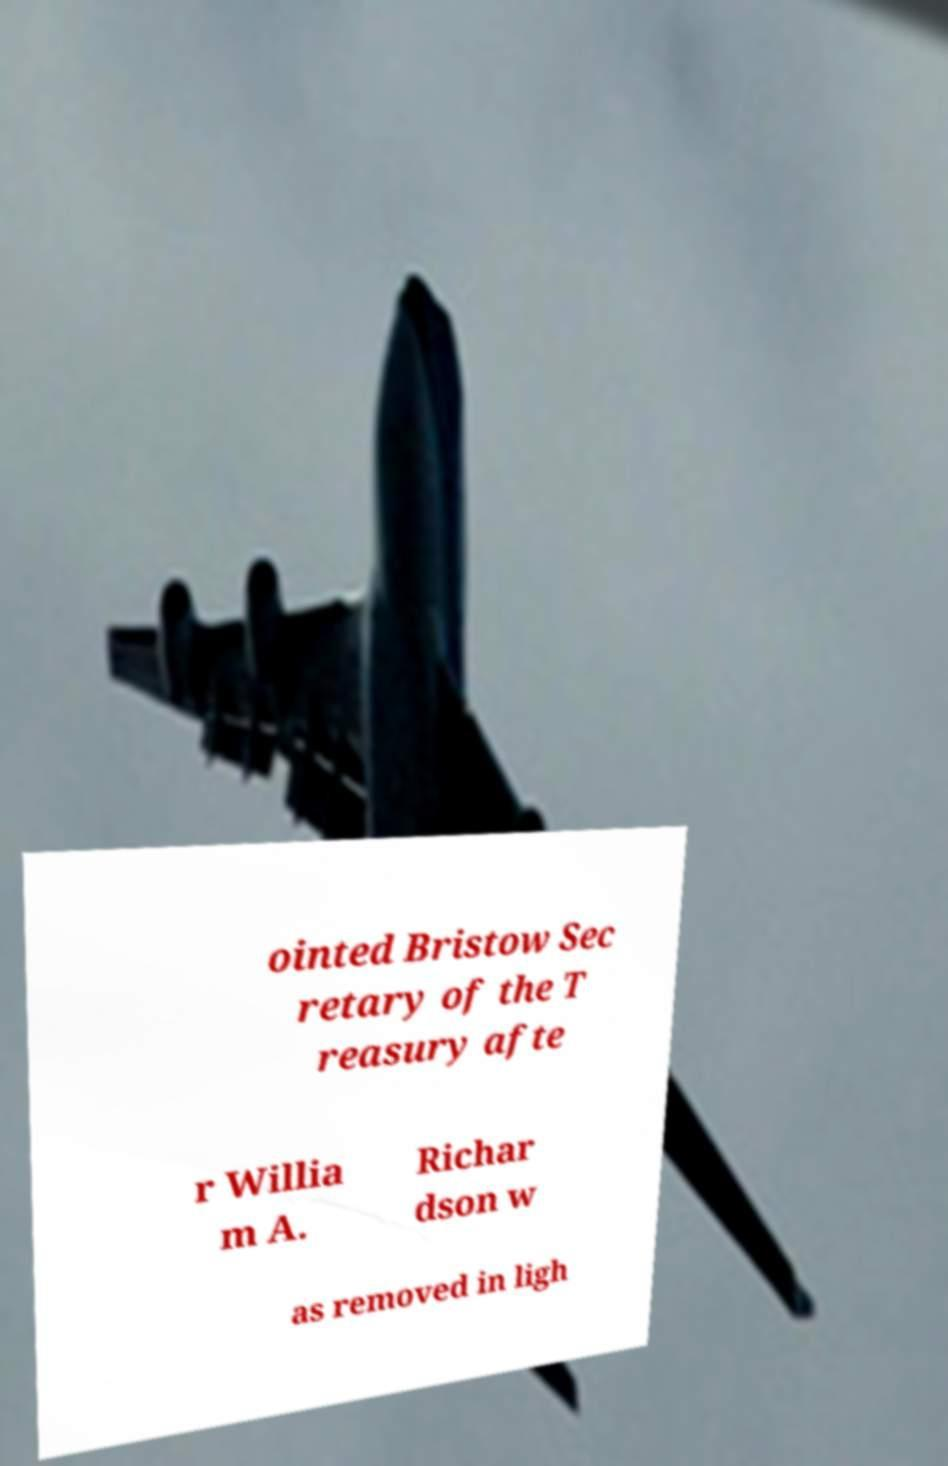Can you accurately transcribe the text from the provided image for me? ointed Bristow Sec retary of the T reasury afte r Willia m A. Richar dson w as removed in ligh 